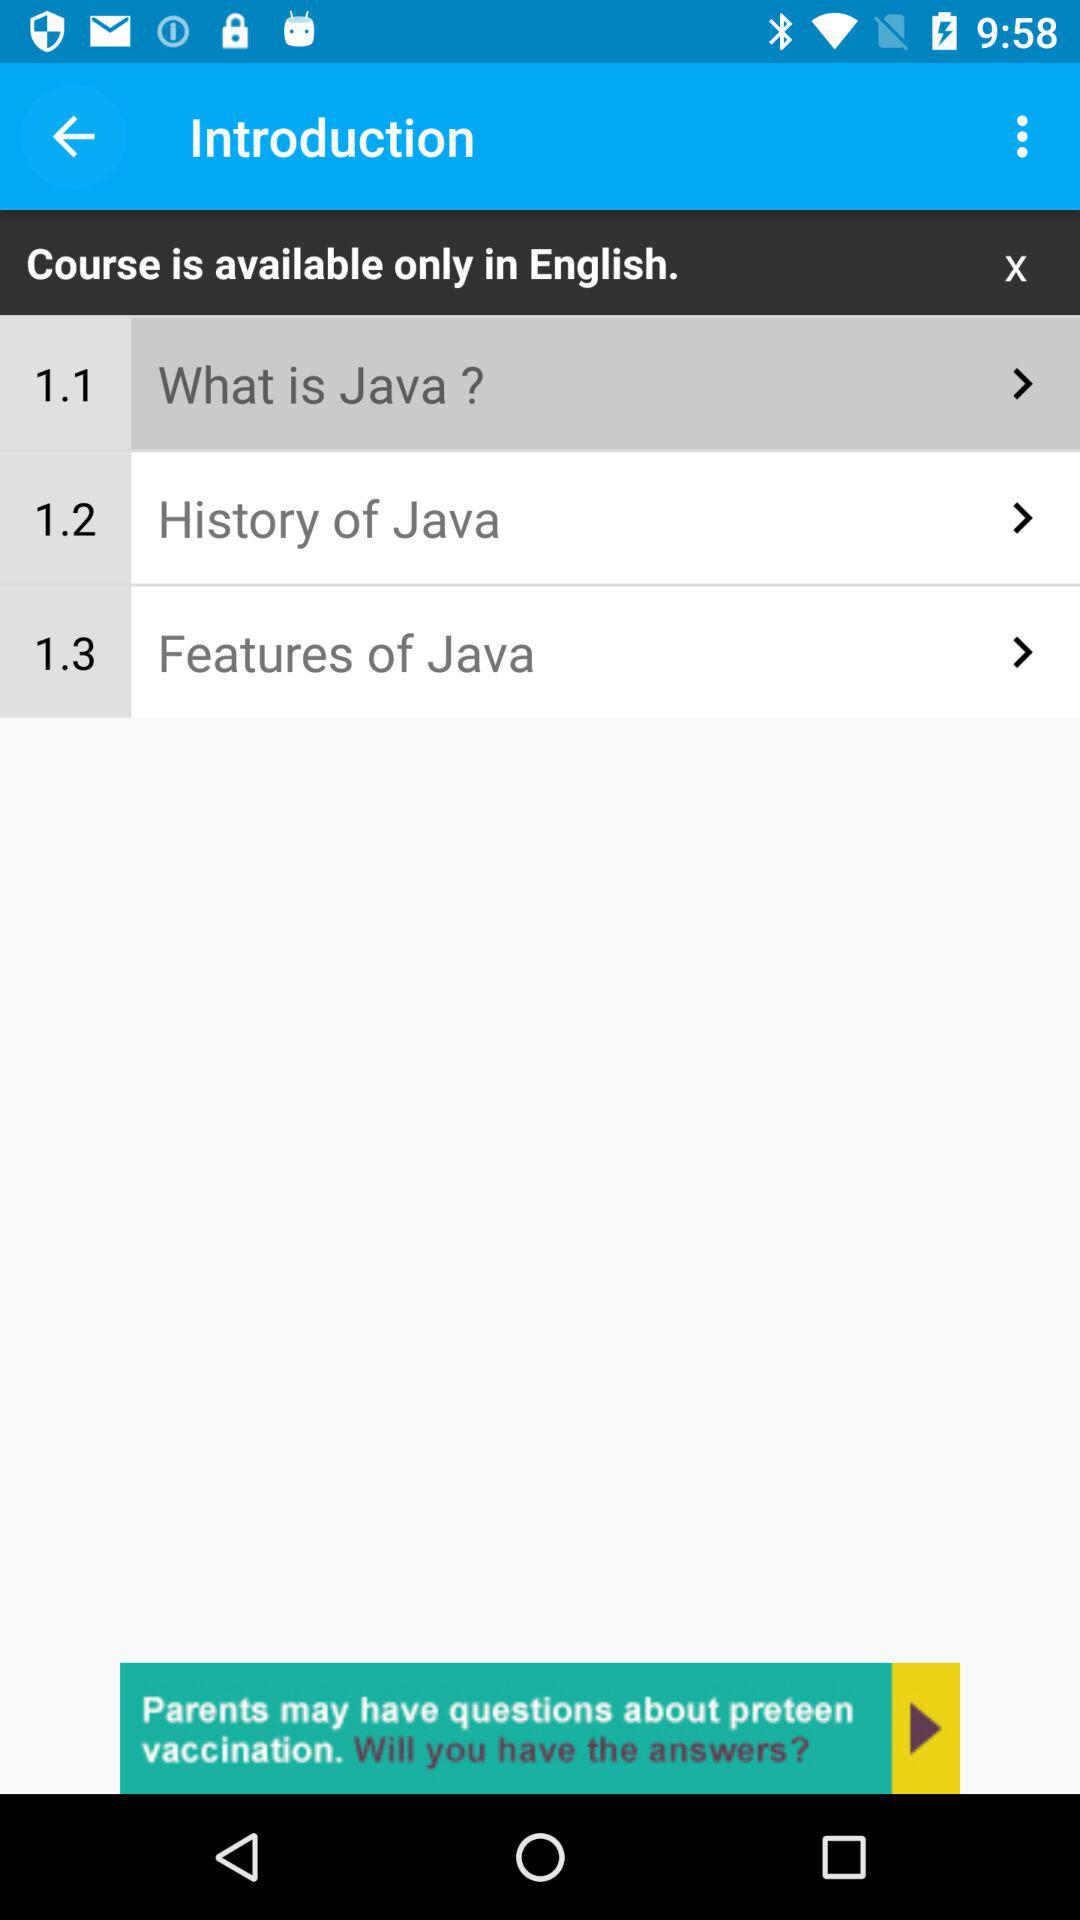What is the duration of "What is Java"?
When the provided information is insufficient, respond with <no answer>. <no answer> 